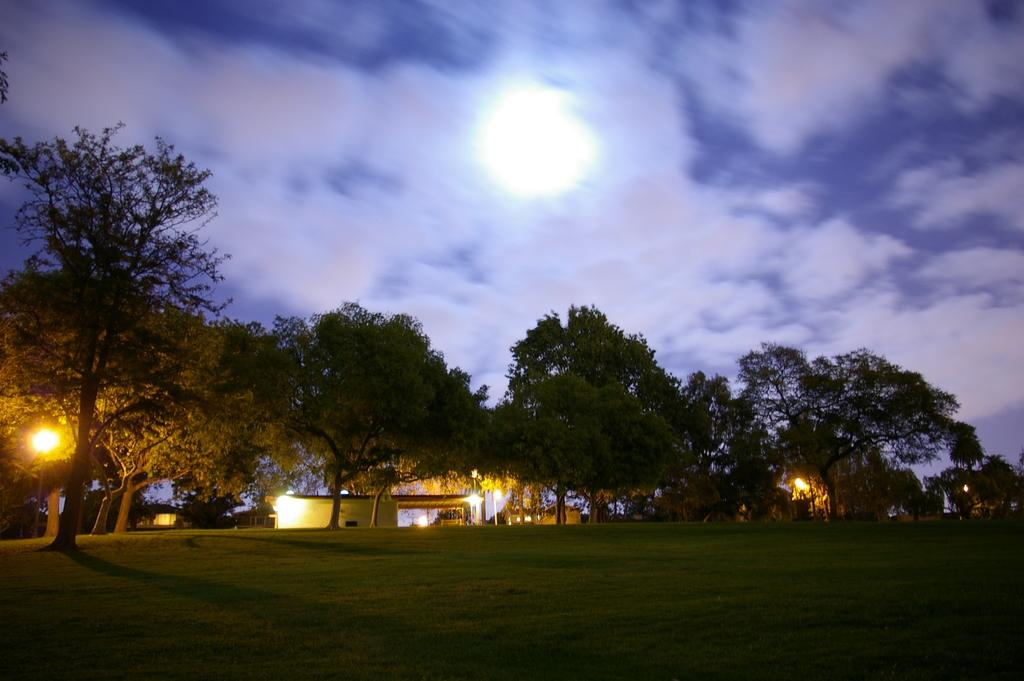What type of vegetation can be seen in the image? There are trees in the image. What type of structures are present in the image? There are houses in the image. What objects are providing illumination in the image? There are lights in the image. What type of ground cover is visible at the bottom of the image? There is grass at the bottom of the image. What can be seen in the background of the image? The sky is visible in the background of the image, with clouds and the full moon. What type of chin can be seen on the full moon in the image? There is no chin present on the full moon in the image, as the moon is a celestial body and not a person. What type of fork is being used to eat the clouds in the image? There are no forks or people eating clouds in the image; the clouds are simply part of the sky. 